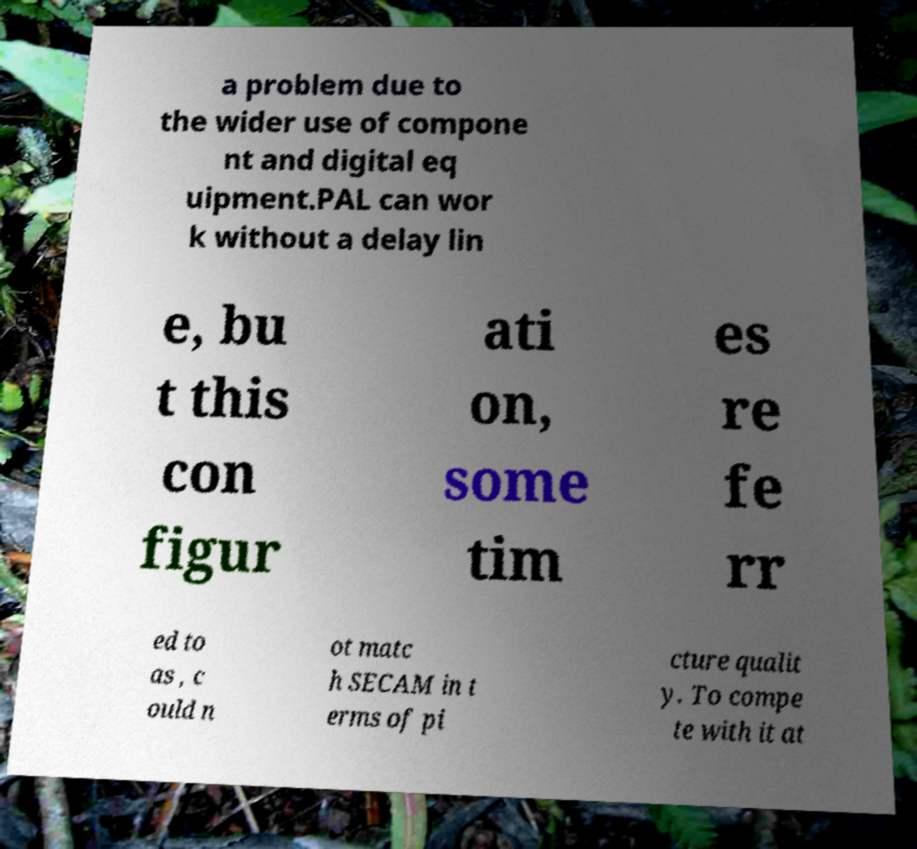Please identify and transcribe the text found in this image. a problem due to the wider use of compone nt and digital eq uipment.PAL can wor k without a delay lin e, bu t this con figur ati on, some tim es re fe rr ed to as , c ould n ot matc h SECAM in t erms of pi cture qualit y. To compe te with it at 